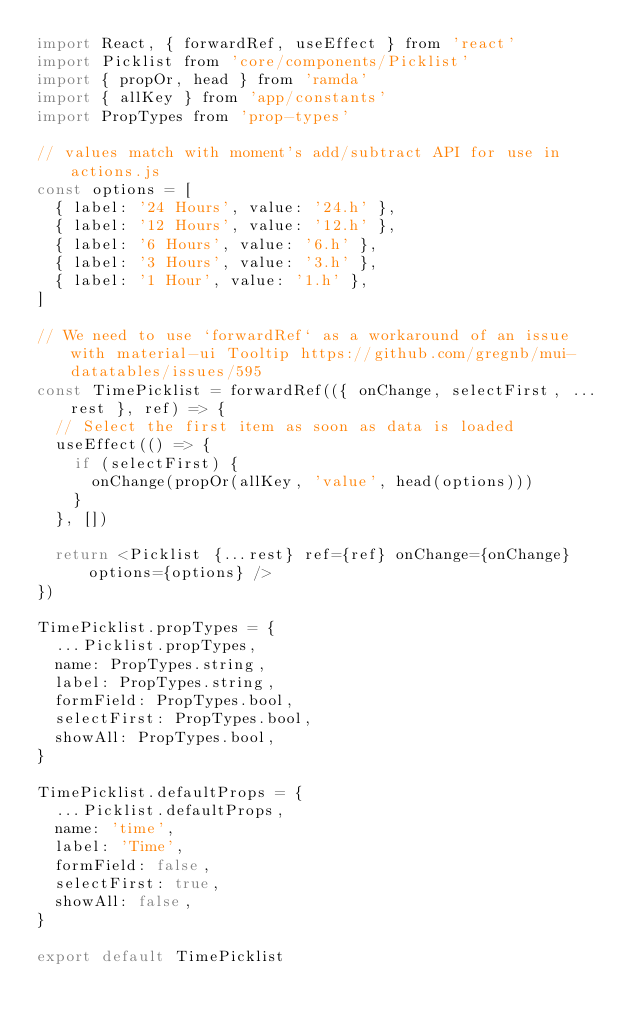<code> <loc_0><loc_0><loc_500><loc_500><_JavaScript_>import React, { forwardRef, useEffect } from 'react'
import Picklist from 'core/components/Picklist'
import { propOr, head } from 'ramda'
import { allKey } from 'app/constants'
import PropTypes from 'prop-types'

// values match with moment's add/subtract API for use in actions.js
const options = [
  { label: '24 Hours', value: '24.h' },
  { label: '12 Hours', value: '12.h' },
  { label: '6 Hours', value: '6.h' },
  { label: '3 Hours', value: '3.h' },
  { label: '1 Hour', value: '1.h' },
]

// We need to use `forwardRef` as a workaround of an issue with material-ui Tooltip https://github.com/gregnb/mui-datatables/issues/595
const TimePicklist = forwardRef(({ onChange, selectFirst, ...rest }, ref) => {
  // Select the first item as soon as data is loaded
  useEffect(() => {
    if (selectFirst) {
      onChange(propOr(allKey, 'value', head(options)))
    }
  }, [])

  return <Picklist {...rest} ref={ref} onChange={onChange} options={options} />
})

TimePicklist.propTypes = {
  ...Picklist.propTypes,
  name: PropTypes.string,
  label: PropTypes.string,
  formField: PropTypes.bool,
  selectFirst: PropTypes.bool,
  showAll: PropTypes.bool,
}

TimePicklist.defaultProps = {
  ...Picklist.defaultProps,
  name: 'time',
  label: 'Time',
  formField: false,
  selectFirst: true,
  showAll: false,
}

export default TimePicklist
</code> 